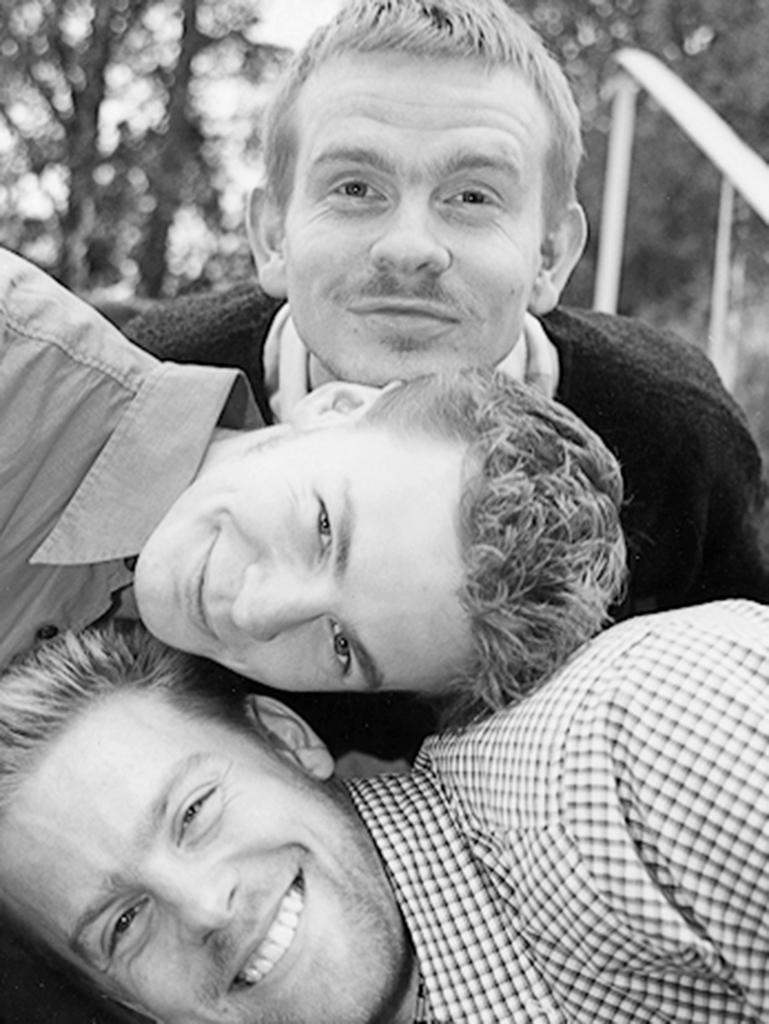How would you summarize this image in a sentence or two? This looks like a black and white image. I can see three men smiling. The background looks blurry. 